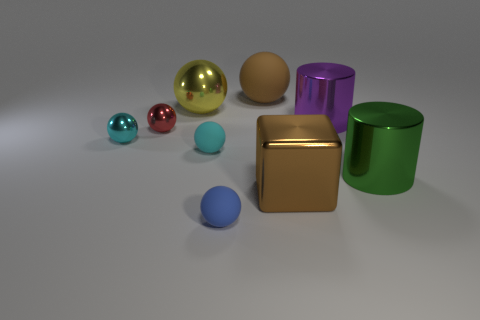What is the size of the brown sphere that is the same material as the blue ball?
Your answer should be compact. Large. What number of small red things are the same shape as the purple thing?
Give a very brief answer. 0. How many large red matte objects are there?
Give a very brief answer. 0. Is the shape of the big metal object behind the purple cylinder the same as  the green shiny thing?
Your answer should be compact. No. What is the material of the yellow object that is the same size as the green cylinder?
Provide a succinct answer. Metal. Is there a tiny red cylinder made of the same material as the big purple cylinder?
Make the answer very short. No. There is a green object; is its shape the same as the purple metallic object that is on the right side of the cyan matte ball?
Provide a short and direct response. Yes. How many balls are on the right side of the large yellow shiny object and behind the purple shiny cylinder?
Ensure brevity in your answer.  1. Is the red sphere made of the same material as the large object on the left side of the brown rubber thing?
Your answer should be compact. Yes. Are there the same number of green shiny things behind the tiny red sphere and yellow objects?
Provide a short and direct response. No. 